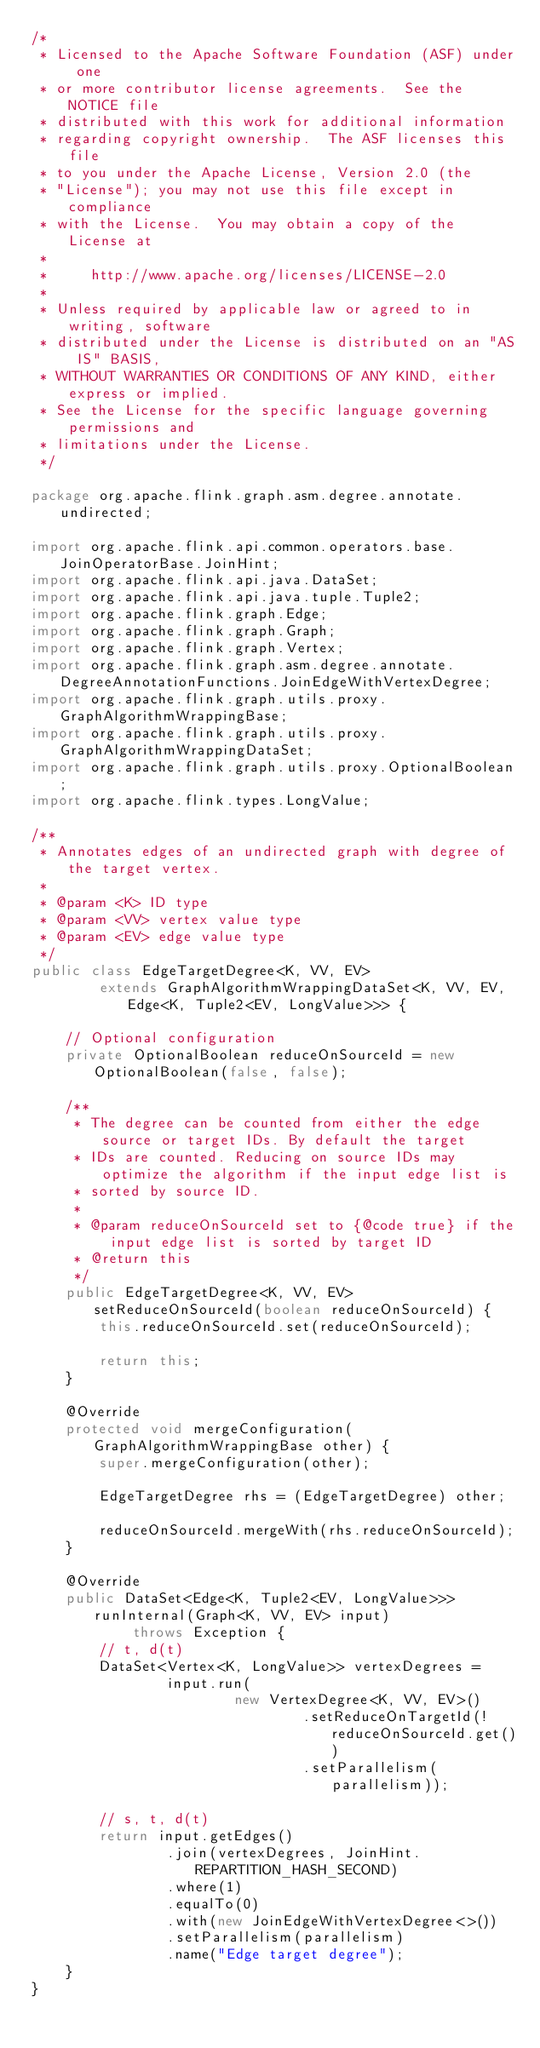<code> <loc_0><loc_0><loc_500><loc_500><_Java_>/*
 * Licensed to the Apache Software Foundation (ASF) under one
 * or more contributor license agreements.  See the NOTICE file
 * distributed with this work for additional information
 * regarding copyright ownership.  The ASF licenses this file
 * to you under the Apache License, Version 2.0 (the
 * "License"); you may not use this file except in compliance
 * with the License.  You may obtain a copy of the License at
 *
 *     http://www.apache.org/licenses/LICENSE-2.0
 *
 * Unless required by applicable law or agreed to in writing, software
 * distributed under the License is distributed on an "AS IS" BASIS,
 * WITHOUT WARRANTIES OR CONDITIONS OF ANY KIND, either express or implied.
 * See the License for the specific language governing permissions and
 * limitations under the License.
 */

package org.apache.flink.graph.asm.degree.annotate.undirected;

import org.apache.flink.api.common.operators.base.JoinOperatorBase.JoinHint;
import org.apache.flink.api.java.DataSet;
import org.apache.flink.api.java.tuple.Tuple2;
import org.apache.flink.graph.Edge;
import org.apache.flink.graph.Graph;
import org.apache.flink.graph.Vertex;
import org.apache.flink.graph.asm.degree.annotate.DegreeAnnotationFunctions.JoinEdgeWithVertexDegree;
import org.apache.flink.graph.utils.proxy.GraphAlgorithmWrappingBase;
import org.apache.flink.graph.utils.proxy.GraphAlgorithmWrappingDataSet;
import org.apache.flink.graph.utils.proxy.OptionalBoolean;
import org.apache.flink.types.LongValue;

/**
 * Annotates edges of an undirected graph with degree of the target vertex.
 *
 * @param <K> ID type
 * @param <VV> vertex value type
 * @param <EV> edge value type
 */
public class EdgeTargetDegree<K, VV, EV>
        extends GraphAlgorithmWrappingDataSet<K, VV, EV, Edge<K, Tuple2<EV, LongValue>>> {

    // Optional configuration
    private OptionalBoolean reduceOnSourceId = new OptionalBoolean(false, false);

    /**
     * The degree can be counted from either the edge source or target IDs. By default the target
     * IDs are counted. Reducing on source IDs may optimize the algorithm if the input edge list is
     * sorted by source ID.
     *
     * @param reduceOnSourceId set to {@code true} if the input edge list is sorted by target ID
     * @return this
     */
    public EdgeTargetDegree<K, VV, EV> setReduceOnSourceId(boolean reduceOnSourceId) {
        this.reduceOnSourceId.set(reduceOnSourceId);

        return this;
    }

    @Override
    protected void mergeConfiguration(GraphAlgorithmWrappingBase other) {
        super.mergeConfiguration(other);

        EdgeTargetDegree rhs = (EdgeTargetDegree) other;

        reduceOnSourceId.mergeWith(rhs.reduceOnSourceId);
    }

    @Override
    public DataSet<Edge<K, Tuple2<EV, LongValue>>> runInternal(Graph<K, VV, EV> input)
            throws Exception {
        // t, d(t)
        DataSet<Vertex<K, LongValue>> vertexDegrees =
                input.run(
                        new VertexDegree<K, VV, EV>()
                                .setReduceOnTargetId(!reduceOnSourceId.get())
                                .setParallelism(parallelism));

        // s, t, d(t)
        return input.getEdges()
                .join(vertexDegrees, JoinHint.REPARTITION_HASH_SECOND)
                .where(1)
                .equalTo(0)
                .with(new JoinEdgeWithVertexDegree<>())
                .setParallelism(parallelism)
                .name("Edge target degree");
    }
}
</code> 